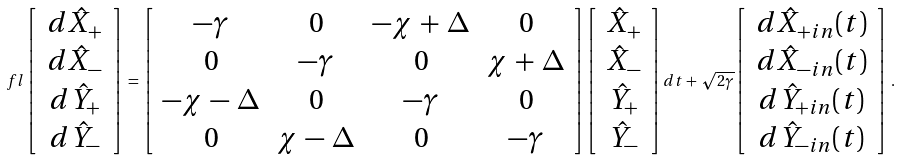Convert formula to latex. <formula><loc_0><loc_0><loc_500><loc_500>\ f l \left [ \, \begin{array} { c } d \hat { X } _ { + } \\ d \hat { X } _ { - } \\ d \hat { Y } _ { + } \\ d \hat { Y } _ { - } \end{array} \, \right ] \, = \, \left [ \begin{array} { c c c c } - \gamma & 0 & - \chi \, + \, \Delta & 0 \\ 0 & - \gamma & 0 & \chi \, + \, \Delta \\ - \chi \, - \, \Delta & 0 & - \gamma & 0 \\ 0 & \chi \, - \, \Delta & 0 & - \gamma \end{array} \right ] \left [ \, \begin{array} { c } \hat { X } _ { + } \\ \hat { X } _ { - } \\ \hat { Y } _ { + } \\ \hat { Y } _ { - } \end{array} \, \right ] d t + \, \sqrt { 2 \gamma } \left [ \, \begin{array} { c } d \hat { X } _ { + i n } ( t ) \\ d \hat { X } _ { - i n } ( t ) \\ d \hat { Y } _ { + i n } ( t ) \\ d \hat { Y } _ { - i n } ( t ) \end{array} \, \right ] \, .</formula> 